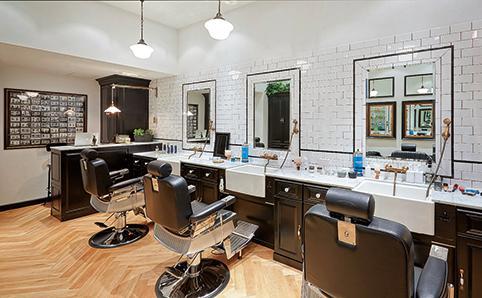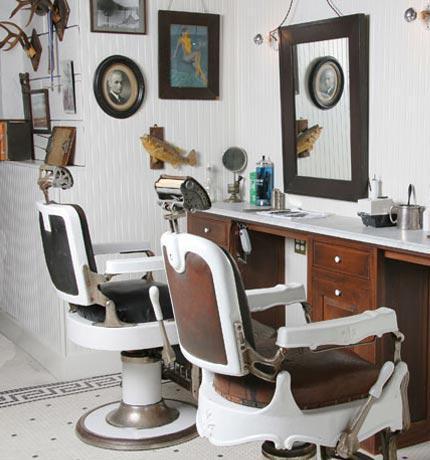The first image is the image on the left, the second image is the image on the right. Assess this claim about the two images: "There are at least two bright red chairs.". Correct or not? Answer yes or no. No. The first image is the image on the left, the second image is the image on the right. Analyze the images presented: Is the assertion "Both rooms are empty." valid? Answer yes or no. Yes. 